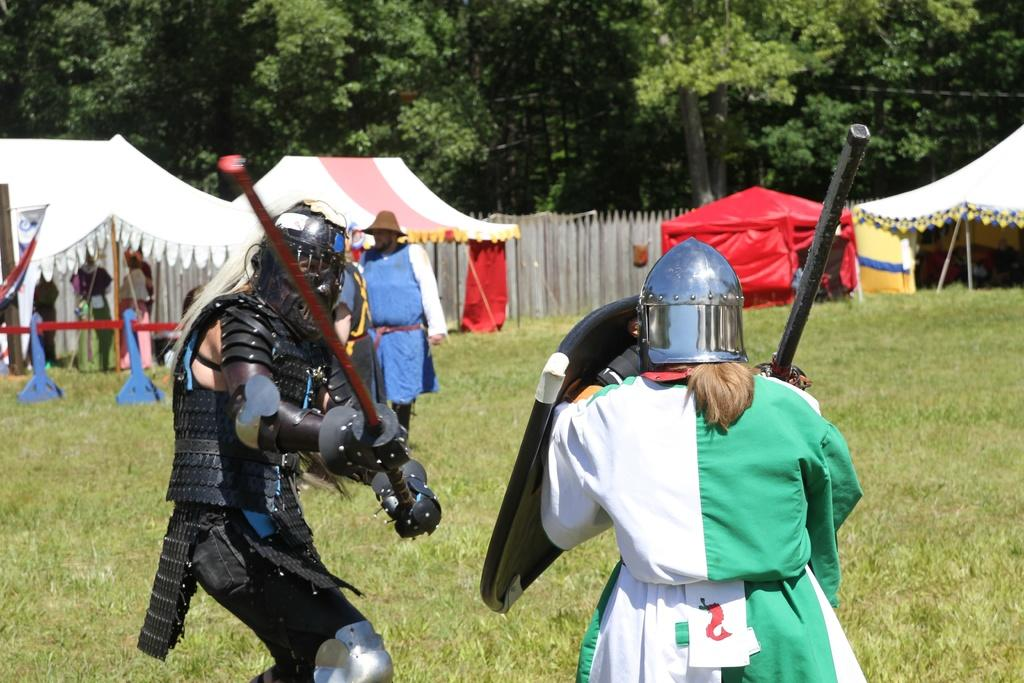What are the people in the image doing? There is a group of people standing on the ground in the image. What structures can be seen in the image? There are tents and a fence visible in the image. What objects are associated with the people in the image? There are shields in the image. What can be seen in the background of the image? There are trees visible in the background of the image. What type of suit is the person wearing in the image? There are no people wearing suits in the image; the people are holding shields. 